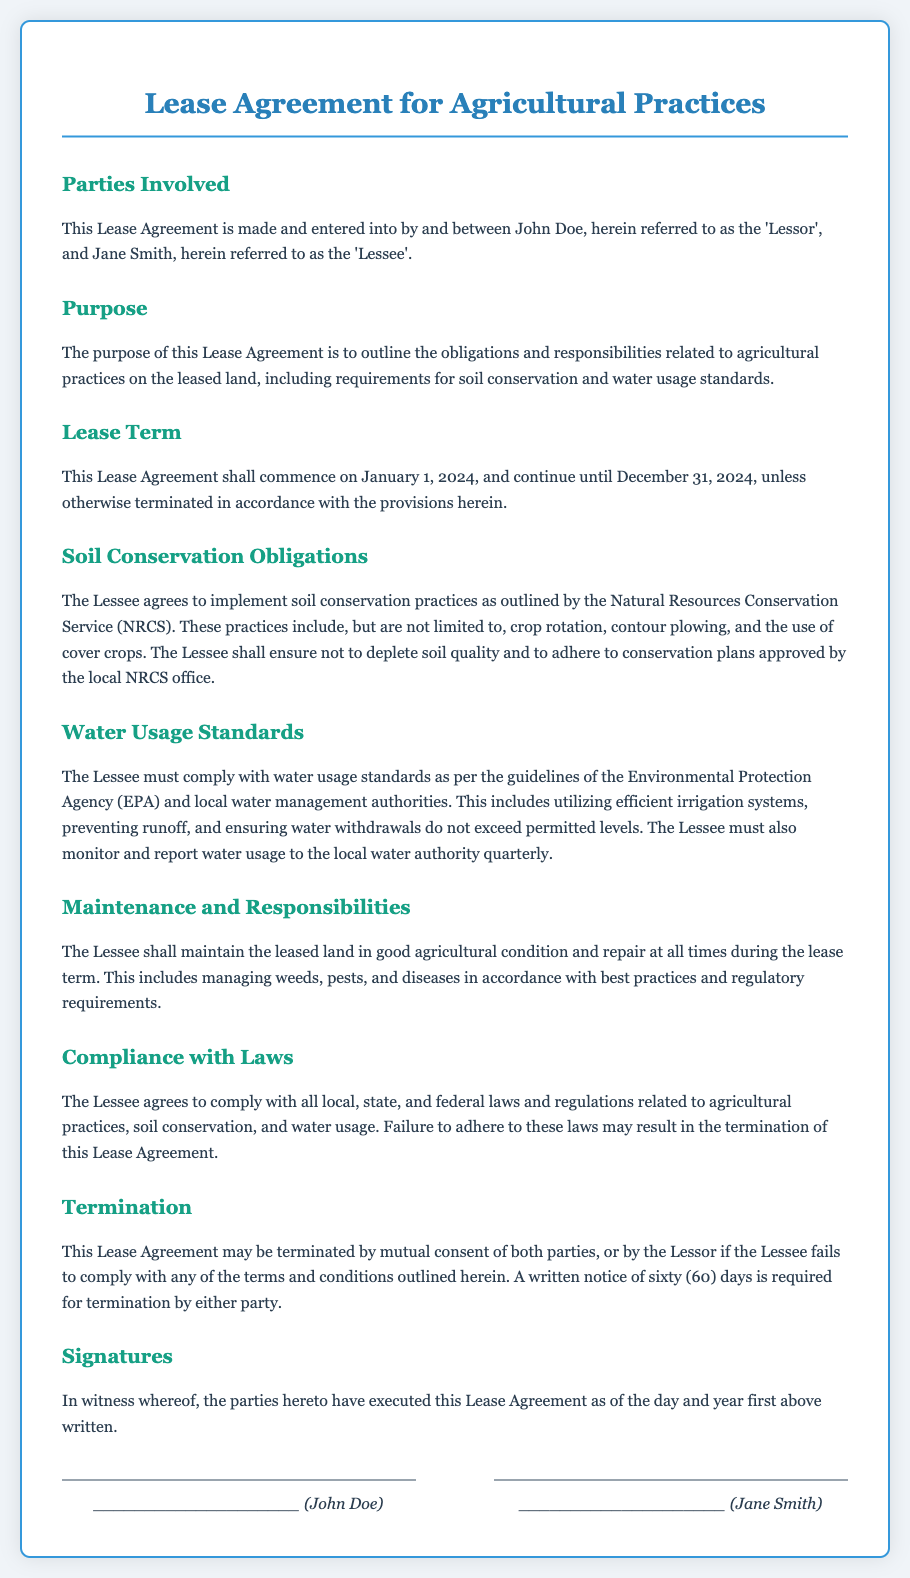What is the name of the Lessor? The Lessor is named John Doe in the document.
Answer: John Doe What is the lease term start date? The lease term begins on January 1, 2024, as stated in the document.
Answer: January 1, 2024 Which practices must the Lessee implement for soil conservation? The Lessee must implement practices outlined by the NRCS, including crop rotation, contour plowing, and use of cover crops.
Answer: Crop rotation, contour plowing, and cover crops What is the water usage reporting frequency? The Lessee must monitor and report water usage quarterly to the local water authority.
Answer: Quarterly What may result from failure to comply with laws? If the Lessee fails to comply with laws, it may result in termination of the Lease Agreement.
Answer: Termination How much notice is required for termination? The document states that a written notice of sixty days is required for termination by either party.
Answer: Sixty days What is the purpose of this Lease Agreement? The purpose is to outline the obligations and responsibilities related to agricultural practices on the leased land.
Answer: Outline obligations and responsibilities Which agency's guidelines must the Lessee follow for water usage? The Lessee must comply with the guidelines of the Environmental Protection Agency and local water management authorities.
Answer: Environmental Protection Agency What responsibilities does the Lessee have regarding the agricultural condition of the land? The Lessee must maintain the leased land in good agricultural condition and repair at all times during the lease term.
Answer: Maintain good agricultural condition 